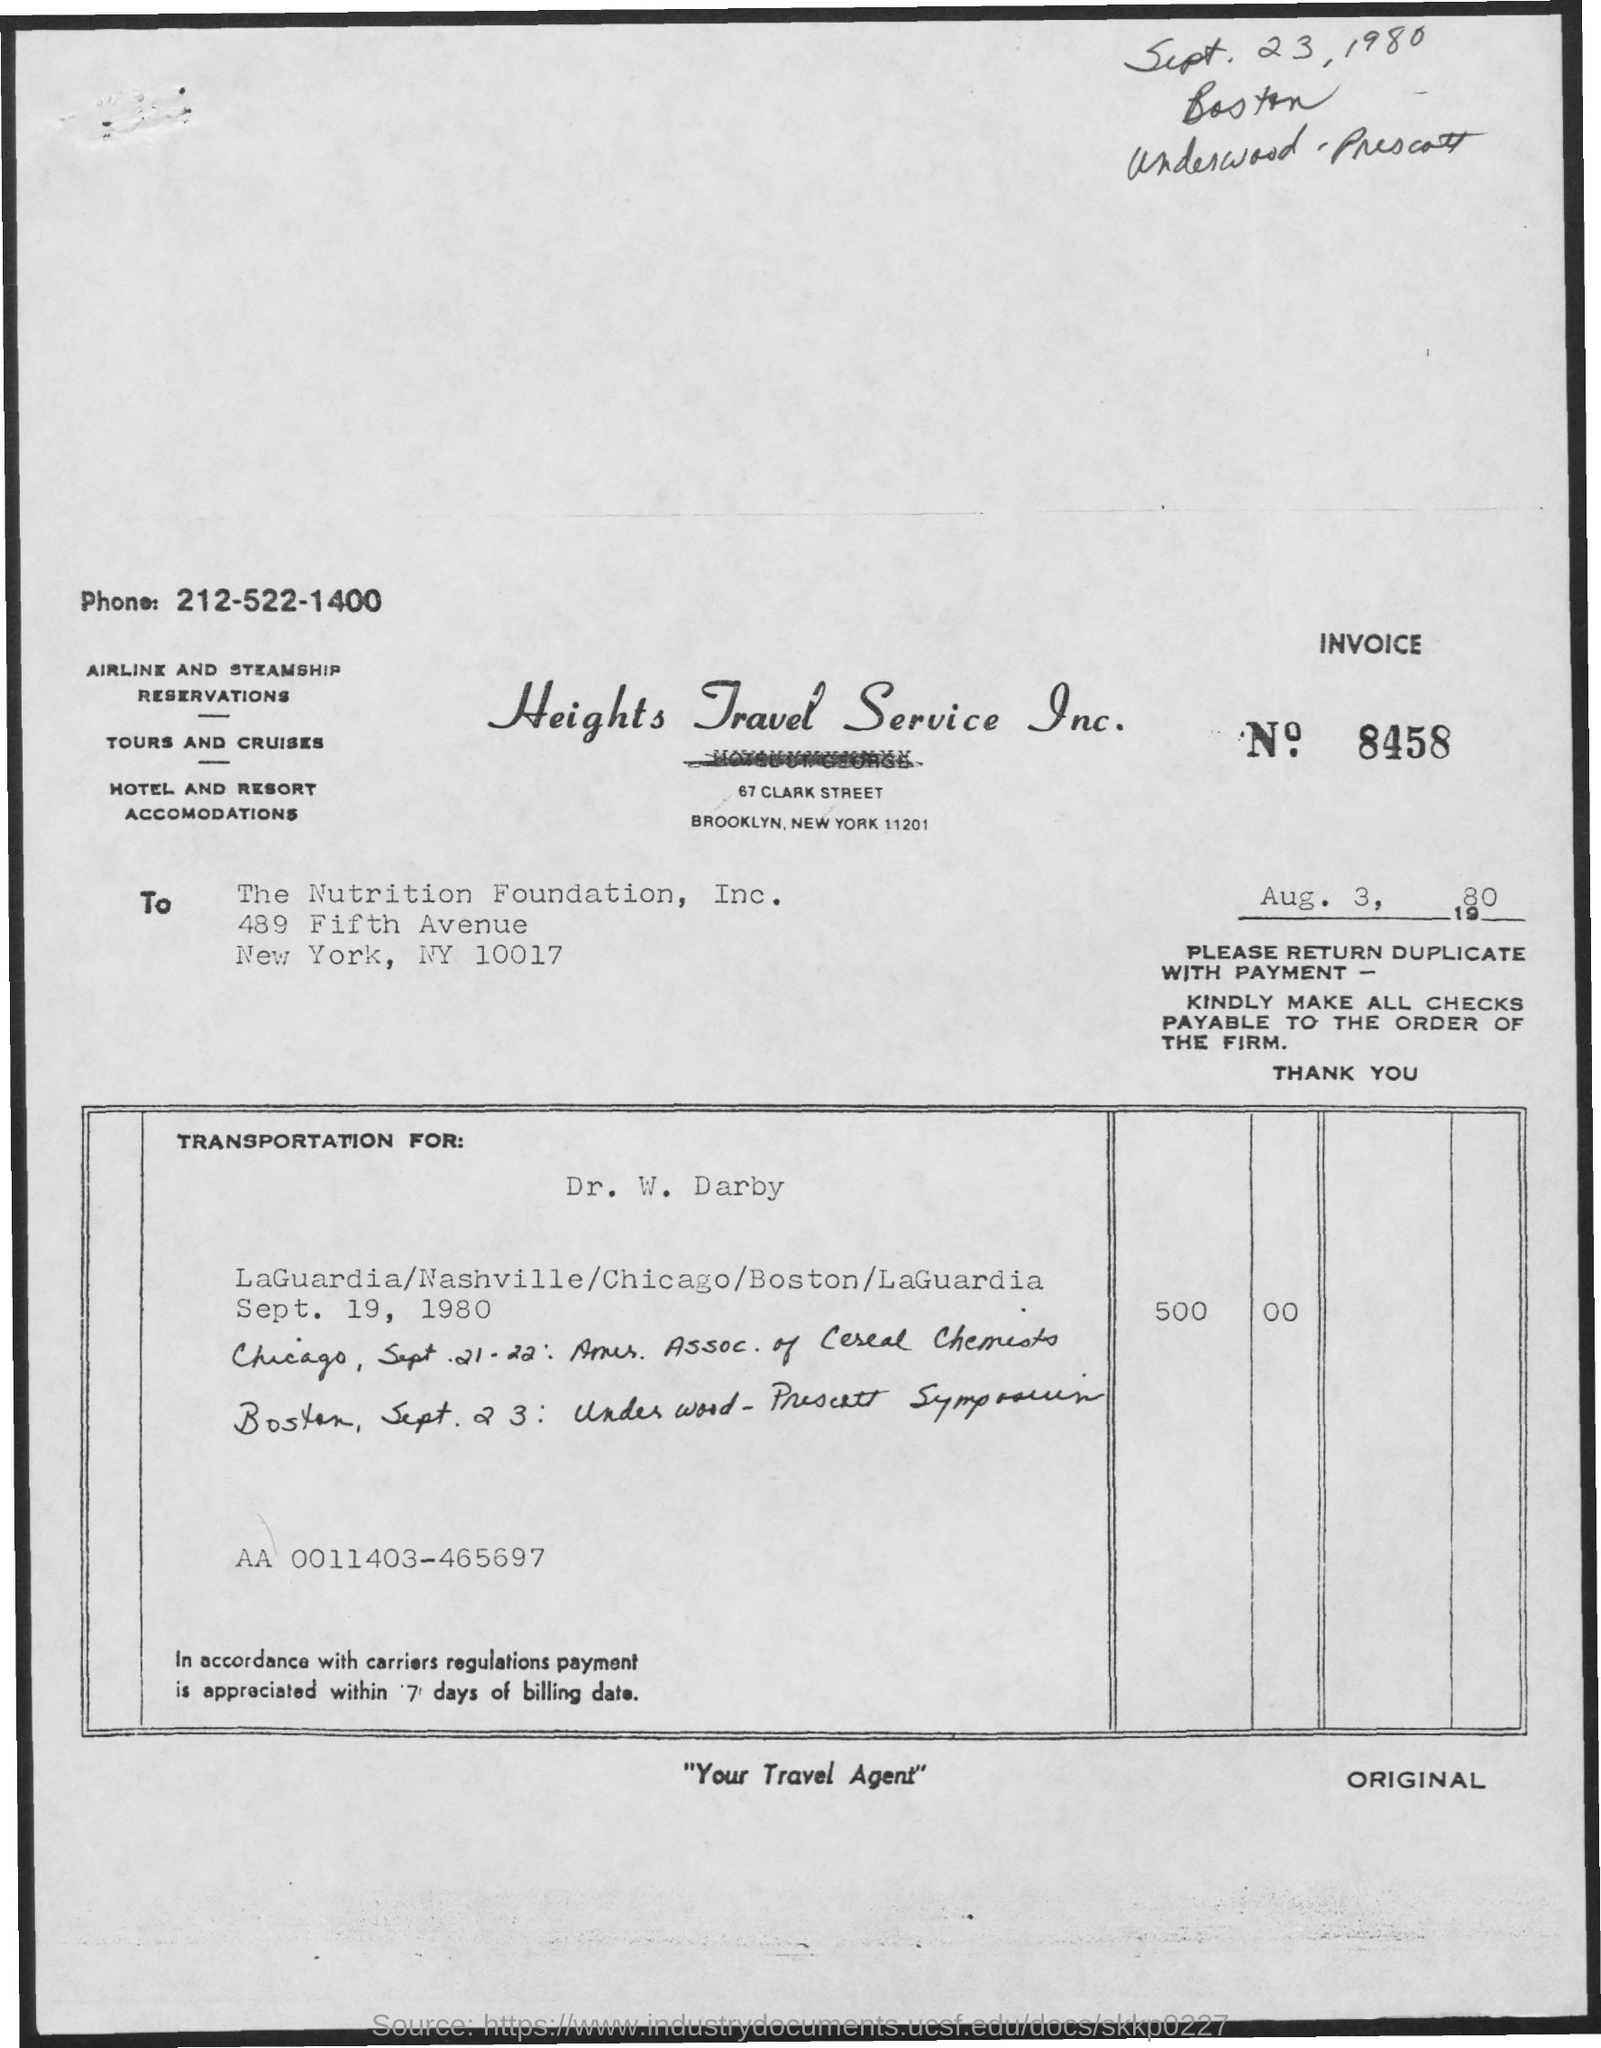What is the date mentioned in the given letter ?
Provide a short and direct response. Aug. 3, 1980. What is the phone no. mentioned in the given letter ?
Your answer should be very brief. 212-522-1400. What is the invoice no. mentioned in the given form ?
Offer a very short reply. 8458. 